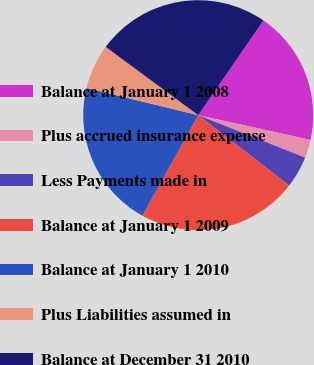<chart> <loc_0><loc_0><loc_500><loc_500><pie_chart><fcel>Balance at January 1 2008<fcel>Plus accrued insurance expense<fcel>Less Payments made in<fcel>Balance at January 1 2009<fcel>Balance at January 1 2010<fcel>Plus Liabilities assumed in<fcel>Balance at December 31 2010<nl><fcel>18.85%<fcel>2.57%<fcel>4.45%<fcel>22.6%<fcel>20.73%<fcel>6.32%<fcel>24.47%<nl></chart> 